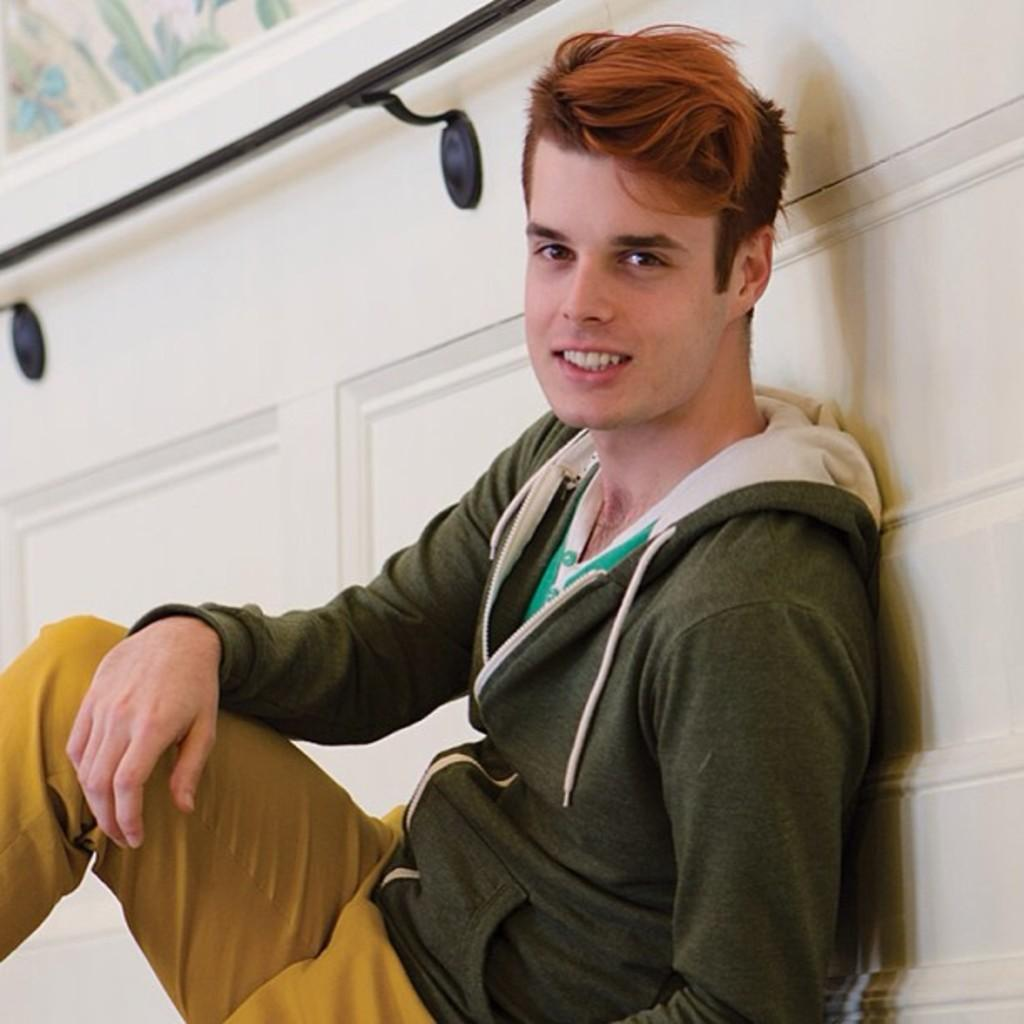What is the main subject of the image? There is a person sitting in the middle of the image. What is the person's facial expression? The person is smiling. What can be seen behind the person? There is a wall behind the person. What type of cord is being used by the person in the image? There is no cord visible in the image. What journey is the person embarking on in the image? The image does not depict a journey or any indication of the person's plans. 